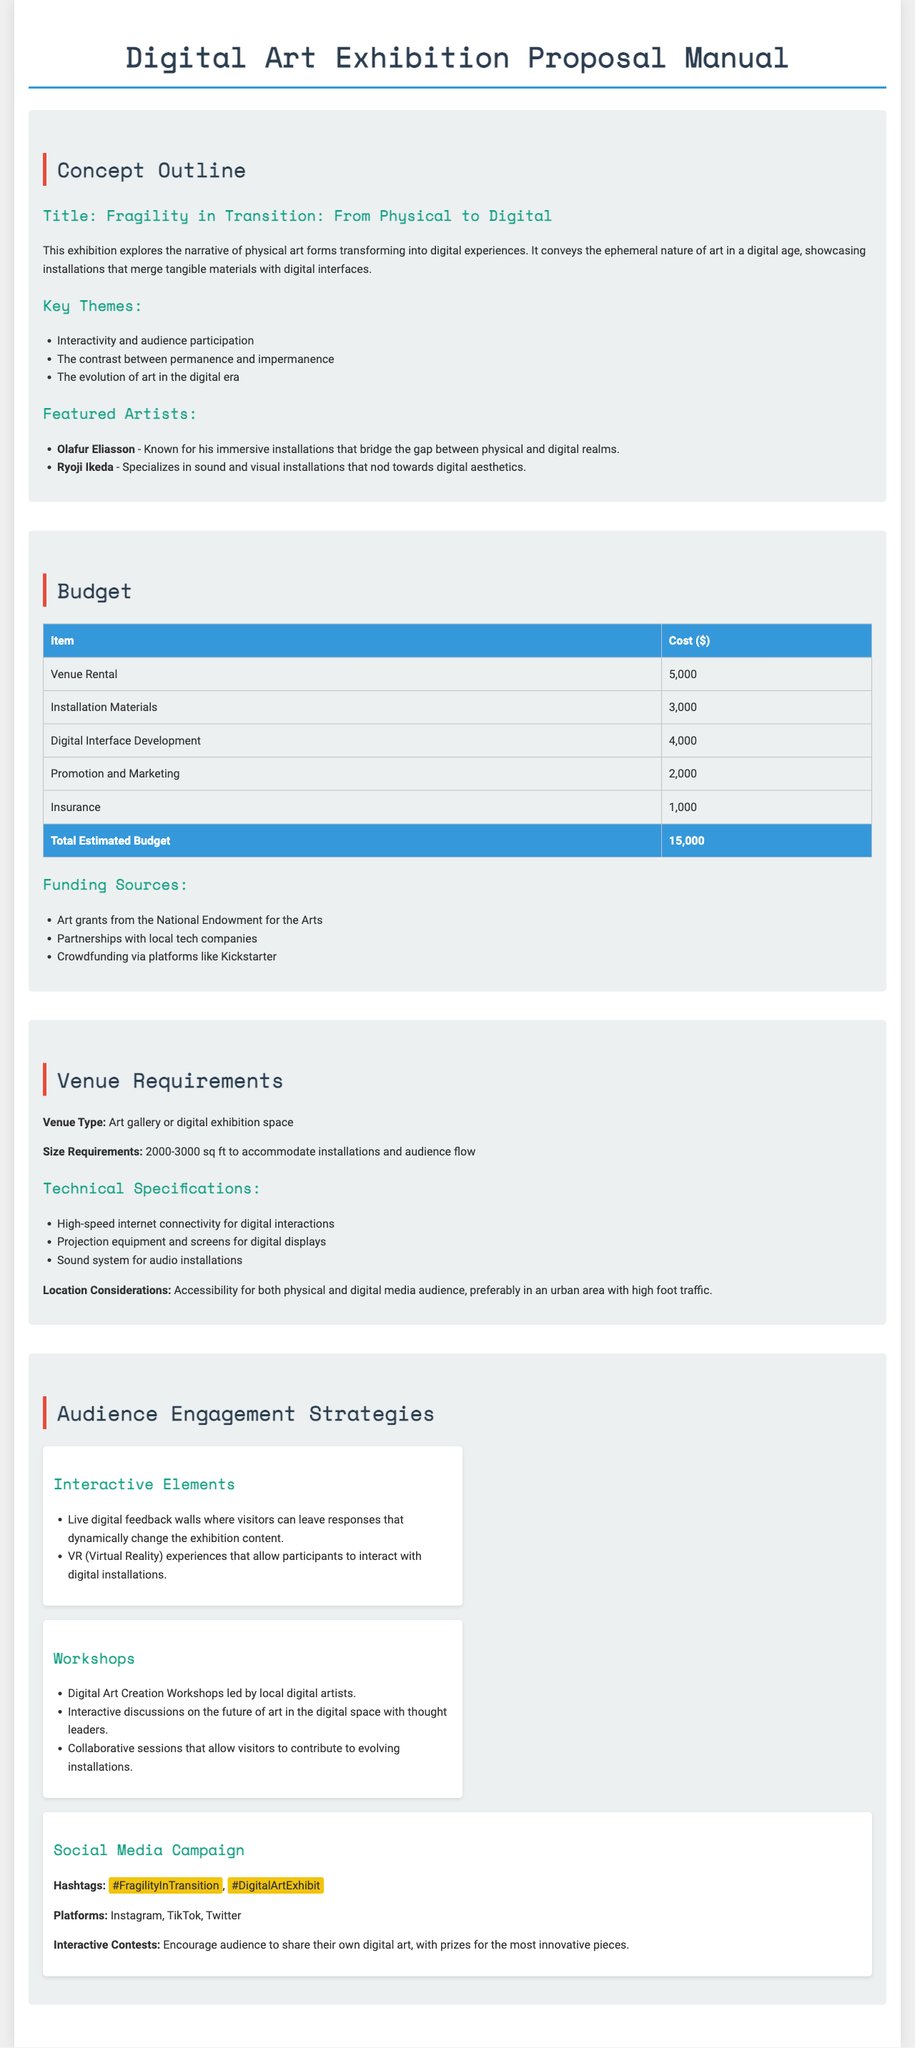what is the title of the exhibition? The title of the exhibition is mentioned in the Concept Outline section.
Answer: Fragility in Transition: From Physical to Digital what is the total estimated budget for the exhibition? The total estimated budget is listed in the Budget section of the document.
Answer: 15,000 which two artists are featured in the exhibition? The featured artists are listed under the Featured Artists subsection in the Concept Outline.
Answer: Olafur Eliasson, Ryoji Ikeda what is one of the key themes of the exhibition? Key themes can be found within the Concept Outline, where multiple themes are listed.
Answer: Interactivity and audience participation how large should the venue be for this exhibition? Size requirements for the venue are specified under Venue Requirements.
Answer: 2000-3000 sq ft which platform is suggested for the social media campaign? The platforms for the social media campaign are listed in the Audience Engagement Strategies section.
Answer: Instagram, TikTok, Twitter what is one technical specification required for the venue? The technical specifications for the venue are mentioned under Venue Requirements.
Answer: High-speed internet connectivity name one funding source for the exhibition. Potential funding sources are outlined in the Budget section of the document.
Answer: Art grants from the National Endowment for the Arts what type of interactive element is proposed for audience engagement? Interactive elements are discussed in the Audience Engagement Strategies section.
Answer: Live digital feedback walls 